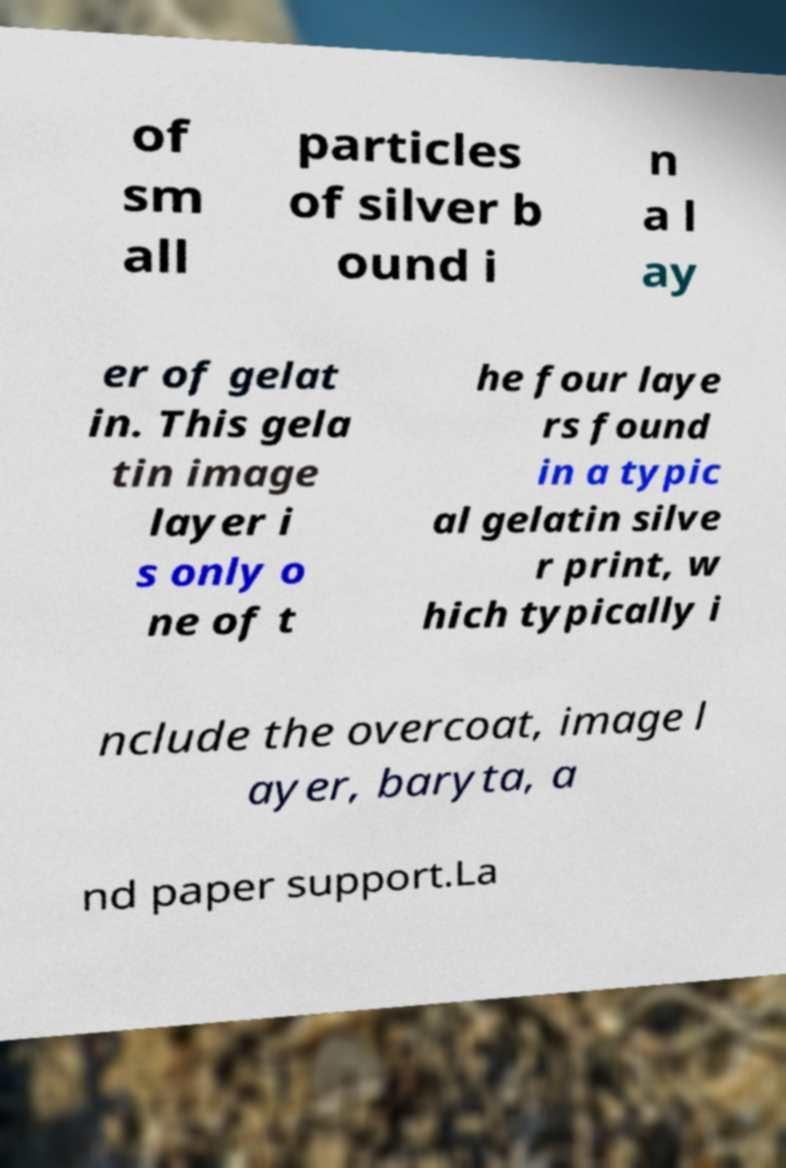Could you assist in decoding the text presented in this image and type it out clearly? of sm all particles of silver b ound i n a l ay er of gelat in. This gela tin image layer i s only o ne of t he four laye rs found in a typic al gelatin silve r print, w hich typically i nclude the overcoat, image l ayer, baryta, a nd paper support.La 